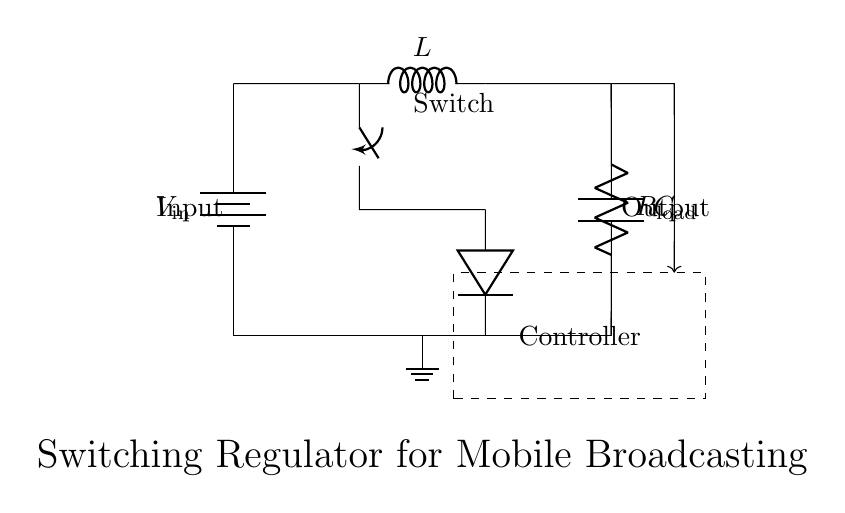What is the type of regulator depicted in the circuit? The circuit shows a switching regulator, identifiable by the switch, inductor, and feedback loop. These components create a system that efficiently converts input voltage to a desired output voltage.
Answer: Switching regulator What is the role of the inductor in this circuit? The inductor stores energy during the switch-on phase and releases it to the load when the switch is off, helping to smooth out the current and maintain a steady output voltage.
Answer: Energy storage What is the purpose of the diode in this circuit? The diode allows current to flow in one direction towards the load, preventing the backflow of current when the switch is turned off, thereby ensuring the circuit maintains output voltage.
Answer: Current protection What connects the switch and the inductor? A short wire connects the switch to the inductor, allowing current from the input to flow through the inductor when the switch is closed.
Answer: Short How does the feedback mechanism function in this regulator? Feedback is used to monitor the output voltage and adjust the duty cycle of the switch to maintain a constant output voltage, thus ensuring efficiency and stability in various operating conditions.
Answer: Voltage regulation What components make up the output section of this circuit? The output section consists of a capacitor and a load resistor, which work together to filter and stabilize the output voltage for the connected device.
Answer: Capacitor and load resistor What is the input voltage symbol in the circuit? The input voltage is denoted by the symbol V in, which represents the power supply for the regulator circuit.
Answer: V in 